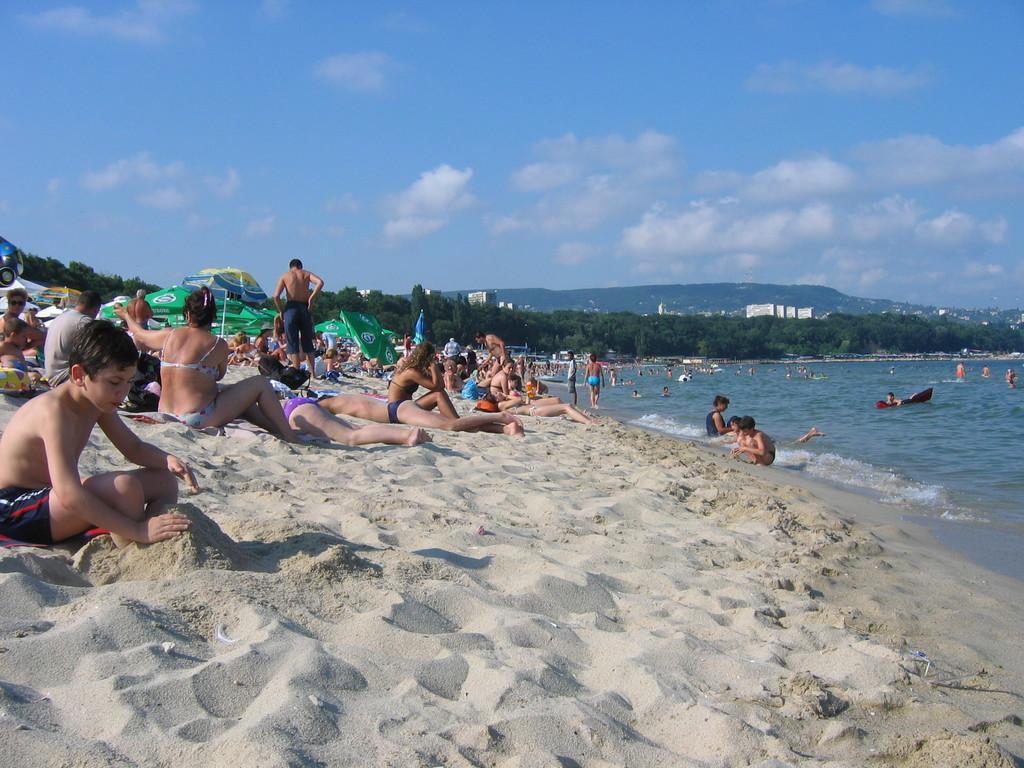Can you describe this image briefly? In this image there is a beach as we can see in middle of this image. There are some person's resting at beach side as we can see at left side of this image. There are some trees in the middle of this image. There are some buildings behind to this trees and there is a mountain at top of this image and there is a sky at top of this image. 